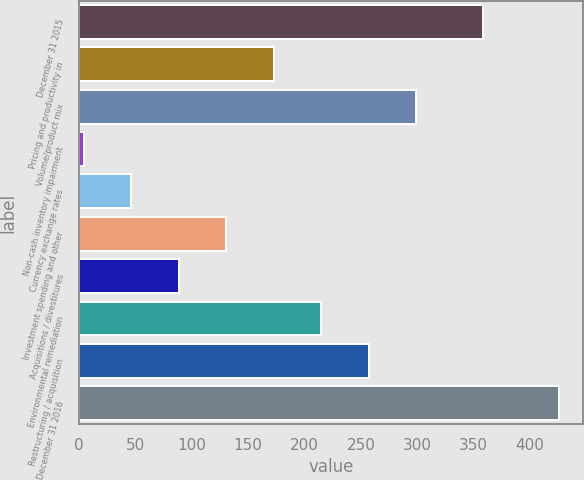Convert chart. <chart><loc_0><loc_0><loc_500><loc_500><bar_chart><fcel>December 31 2015<fcel>Pricing and productivity in<fcel>Volume/product mix<fcel>Non-cash inventory impairment<fcel>Currency exchange rates<fcel>Investment spending and other<fcel>Acquisitions / divestitures<fcel>Environmental remediation<fcel>Restructuring / acquisition<fcel>December 31 2016<nl><fcel>358.6<fcel>172.72<fcel>299.11<fcel>4.2<fcel>46.33<fcel>130.59<fcel>88.46<fcel>214.85<fcel>256.98<fcel>425.5<nl></chart> 